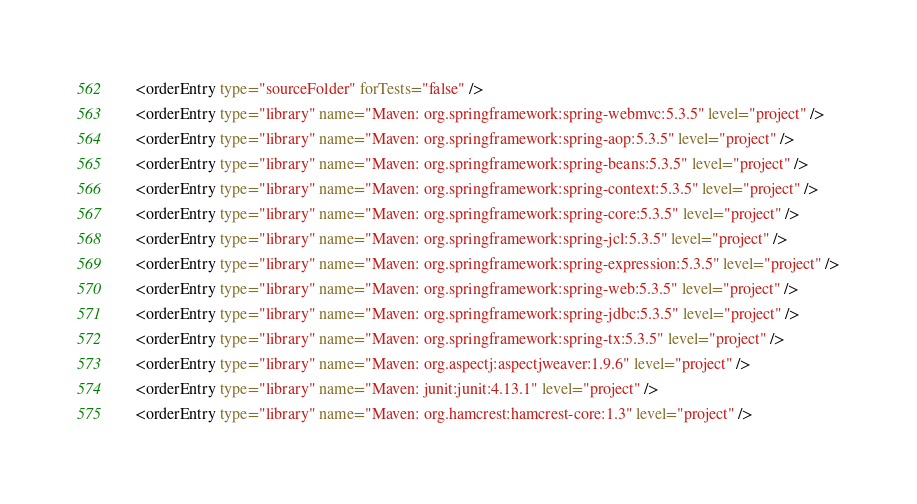<code> <loc_0><loc_0><loc_500><loc_500><_XML_>    <orderEntry type="sourceFolder" forTests="false" />
    <orderEntry type="library" name="Maven: org.springframework:spring-webmvc:5.3.5" level="project" />
    <orderEntry type="library" name="Maven: org.springframework:spring-aop:5.3.5" level="project" />
    <orderEntry type="library" name="Maven: org.springframework:spring-beans:5.3.5" level="project" />
    <orderEntry type="library" name="Maven: org.springframework:spring-context:5.3.5" level="project" />
    <orderEntry type="library" name="Maven: org.springframework:spring-core:5.3.5" level="project" />
    <orderEntry type="library" name="Maven: org.springframework:spring-jcl:5.3.5" level="project" />
    <orderEntry type="library" name="Maven: org.springframework:spring-expression:5.3.5" level="project" />
    <orderEntry type="library" name="Maven: org.springframework:spring-web:5.3.5" level="project" />
    <orderEntry type="library" name="Maven: org.springframework:spring-jdbc:5.3.5" level="project" />
    <orderEntry type="library" name="Maven: org.springframework:spring-tx:5.3.5" level="project" />
    <orderEntry type="library" name="Maven: org.aspectj:aspectjweaver:1.9.6" level="project" />
    <orderEntry type="library" name="Maven: junit:junit:4.13.1" level="project" />
    <orderEntry type="library" name="Maven: org.hamcrest:hamcrest-core:1.3" level="project" /></code> 